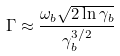Convert formula to latex. <formula><loc_0><loc_0><loc_500><loc_500>\Gamma \approx \frac { \omega _ { b } \sqrt { 2 \ln \gamma _ { b } } } { \gamma _ { b } ^ { 3 / 2 } }</formula> 